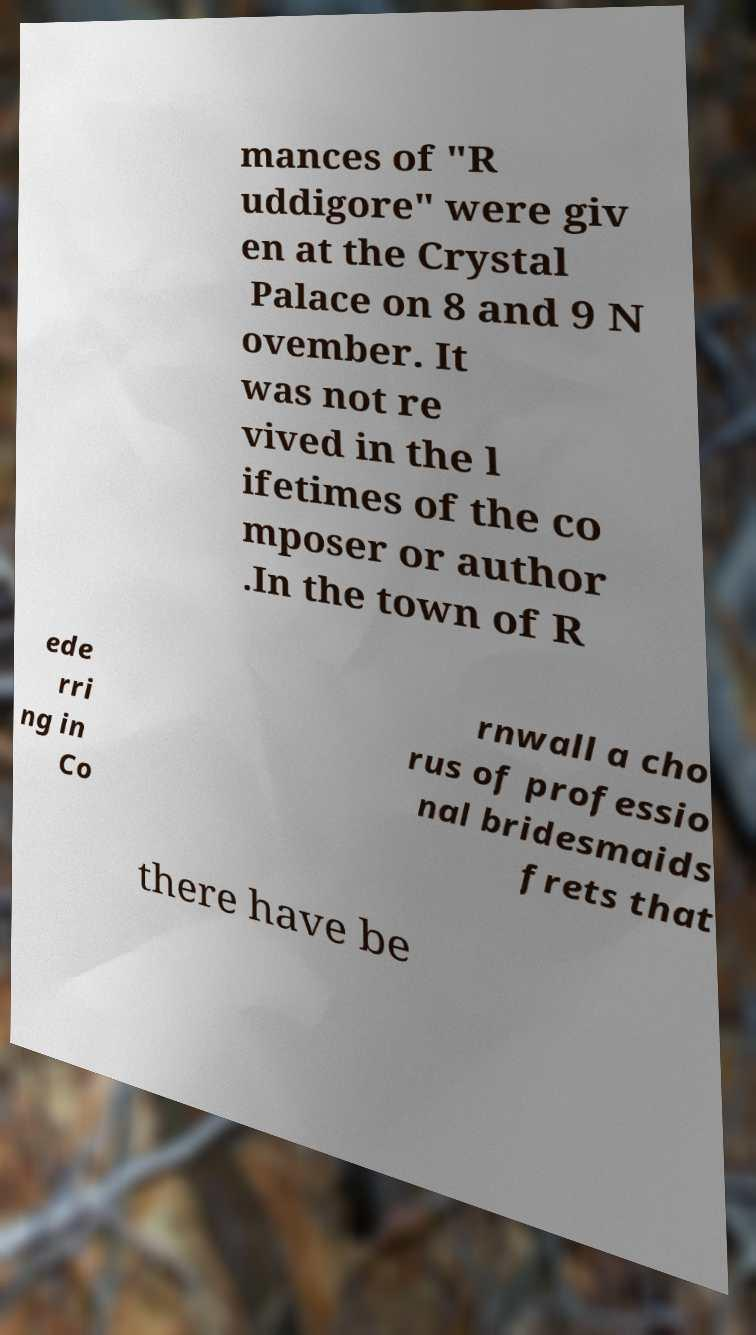What messages or text are displayed in this image? I need them in a readable, typed format. mances of "R uddigore" were giv en at the Crystal Palace on 8 and 9 N ovember. It was not re vived in the l ifetimes of the co mposer or author .In the town of R ede rri ng in Co rnwall a cho rus of professio nal bridesmaids frets that there have be 